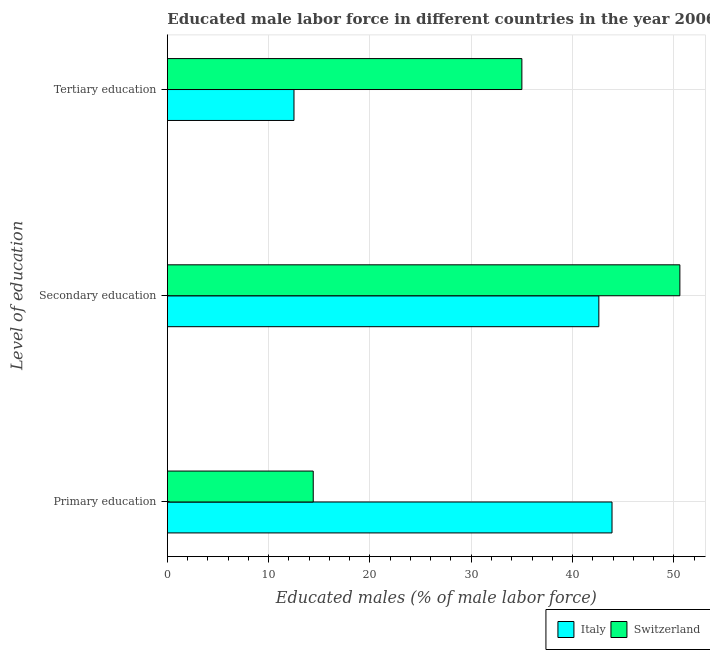How many different coloured bars are there?
Your answer should be compact. 2. Are the number of bars per tick equal to the number of legend labels?
Make the answer very short. Yes. Are the number of bars on each tick of the Y-axis equal?
Your answer should be very brief. Yes. How many bars are there on the 3rd tick from the bottom?
Provide a short and direct response. 2. What is the label of the 1st group of bars from the top?
Keep it short and to the point. Tertiary education. What is the percentage of male labor force who received tertiary education in Switzerland?
Offer a terse response. 35. Across all countries, what is the maximum percentage of male labor force who received secondary education?
Offer a terse response. 50.6. Across all countries, what is the minimum percentage of male labor force who received primary education?
Your answer should be very brief. 14.4. In which country was the percentage of male labor force who received primary education maximum?
Offer a very short reply. Italy. In which country was the percentage of male labor force who received secondary education minimum?
Your response must be concise. Italy. What is the total percentage of male labor force who received secondary education in the graph?
Your answer should be compact. 93.2. What is the difference between the percentage of male labor force who received secondary education in Italy and the percentage of male labor force who received primary education in Switzerland?
Your answer should be compact. 28.2. What is the average percentage of male labor force who received secondary education per country?
Make the answer very short. 46.6. What is the difference between the percentage of male labor force who received tertiary education and percentage of male labor force who received secondary education in Switzerland?
Your answer should be very brief. -15.6. In how many countries, is the percentage of male labor force who received secondary education greater than 38 %?
Offer a terse response. 2. What is the ratio of the percentage of male labor force who received secondary education in Italy to that in Switzerland?
Provide a succinct answer. 0.84. Is the difference between the percentage of male labor force who received tertiary education in Switzerland and Italy greater than the difference between the percentage of male labor force who received primary education in Switzerland and Italy?
Provide a succinct answer. Yes. What is the difference between the highest and the lowest percentage of male labor force who received secondary education?
Your answer should be very brief. 8. Is the sum of the percentage of male labor force who received tertiary education in Italy and Switzerland greater than the maximum percentage of male labor force who received secondary education across all countries?
Keep it short and to the point. No. What does the 1st bar from the top in Secondary education represents?
Provide a succinct answer. Switzerland. What does the 1st bar from the bottom in Secondary education represents?
Your answer should be very brief. Italy. Are all the bars in the graph horizontal?
Make the answer very short. Yes. How many countries are there in the graph?
Your response must be concise. 2. What is the difference between two consecutive major ticks on the X-axis?
Your answer should be very brief. 10. Are the values on the major ticks of X-axis written in scientific E-notation?
Your answer should be very brief. No. How many legend labels are there?
Your answer should be very brief. 2. What is the title of the graph?
Provide a succinct answer. Educated male labor force in different countries in the year 2006. What is the label or title of the X-axis?
Offer a very short reply. Educated males (% of male labor force). What is the label or title of the Y-axis?
Your answer should be very brief. Level of education. What is the Educated males (% of male labor force) in Italy in Primary education?
Offer a very short reply. 43.9. What is the Educated males (% of male labor force) in Switzerland in Primary education?
Give a very brief answer. 14.4. What is the Educated males (% of male labor force) of Italy in Secondary education?
Offer a very short reply. 42.6. What is the Educated males (% of male labor force) of Switzerland in Secondary education?
Provide a short and direct response. 50.6. Across all Level of education, what is the maximum Educated males (% of male labor force) in Italy?
Your answer should be very brief. 43.9. Across all Level of education, what is the maximum Educated males (% of male labor force) of Switzerland?
Offer a very short reply. 50.6. Across all Level of education, what is the minimum Educated males (% of male labor force) in Italy?
Provide a short and direct response. 12.5. Across all Level of education, what is the minimum Educated males (% of male labor force) of Switzerland?
Give a very brief answer. 14.4. What is the difference between the Educated males (% of male labor force) in Italy in Primary education and that in Secondary education?
Give a very brief answer. 1.3. What is the difference between the Educated males (% of male labor force) of Switzerland in Primary education and that in Secondary education?
Provide a short and direct response. -36.2. What is the difference between the Educated males (% of male labor force) in Italy in Primary education and that in Tertiary education?
Make the answer very short. 31.4. What is the difference between the Educated males (% of male labor force) in Switzerland in Primary education and that in Tertiary education?
Offer a very short reply. -20.6. What is the difference between the Educated males (% of male labor force) of Italy in Secondary education and that in Tertiary education?
Provide a succinct answer. 30.1. What is the difference between the Educated males (% of male labor force) of Italy in Primary education and the Educated males (% of male labor force) of Switzerland in Secondary education?
Your response must be concise. -6.7. What is the average Educated males (% of male labor force) in Switzerland per Level of education?
Provide a succinct answer. 33.33. What is the difference between the Educated males (% of male labor force) in Italy and Educated males (% of male labor force) in Switzerland in Primary education?
Make the answer very short. 29.5. What is the difference between the Educated males (% of male labor force) in Italy and Educated males (% of male labor force) in Switzerland in Tertiary education?
Your answer should be very brief. -22.5. What is the ratio of the Educated males (% of male labor force) of Italy in Primary education to that in Secondary education?
Keep it short and to the point. 1.03. What is the ratio of the Educated males (% of male labor force) of Switzerland in Primary education to that in Secondary education?
Make the answer very short. 0.28. What is the ratio of the Educated males (% of male labor force) in Italy in Primary education to that in Tertiary education?
Your answer should be compact. 3.51. What is the ratio of the Educated males (% of male labor force) of Switzerland in Primary education to that in Tertiary education?
Your answer should be compact. 0.41. What is the ratio of the Educated males (% of male labor force) in Italy in Secondary education to that in Tertiary education?
Provide a short and direct response. 3.41. What is the ratio of the Educated males (% of male labor force) in Switzerland in Secondary education to that in Tertiary education?
Provide a short and direct response. 1.45. What is the difference between the highest and the second highest Educated males (% of male labor force) in Italy?
Ensure brevity in your answer.  1.3. What is the difference between the highest and the second highest Educated males (% of male labor force) of Switzerland?
Your answer should be compact. 15.6. What is the difference between the highest and the lowest Educated males (% of male labor force) in Italy?
Your answer should be compact. 31.4. What is the difference between the highest and the lowest Educated males (% of male labor force) in Switzerland?
Make the answer very short. 36.2. 